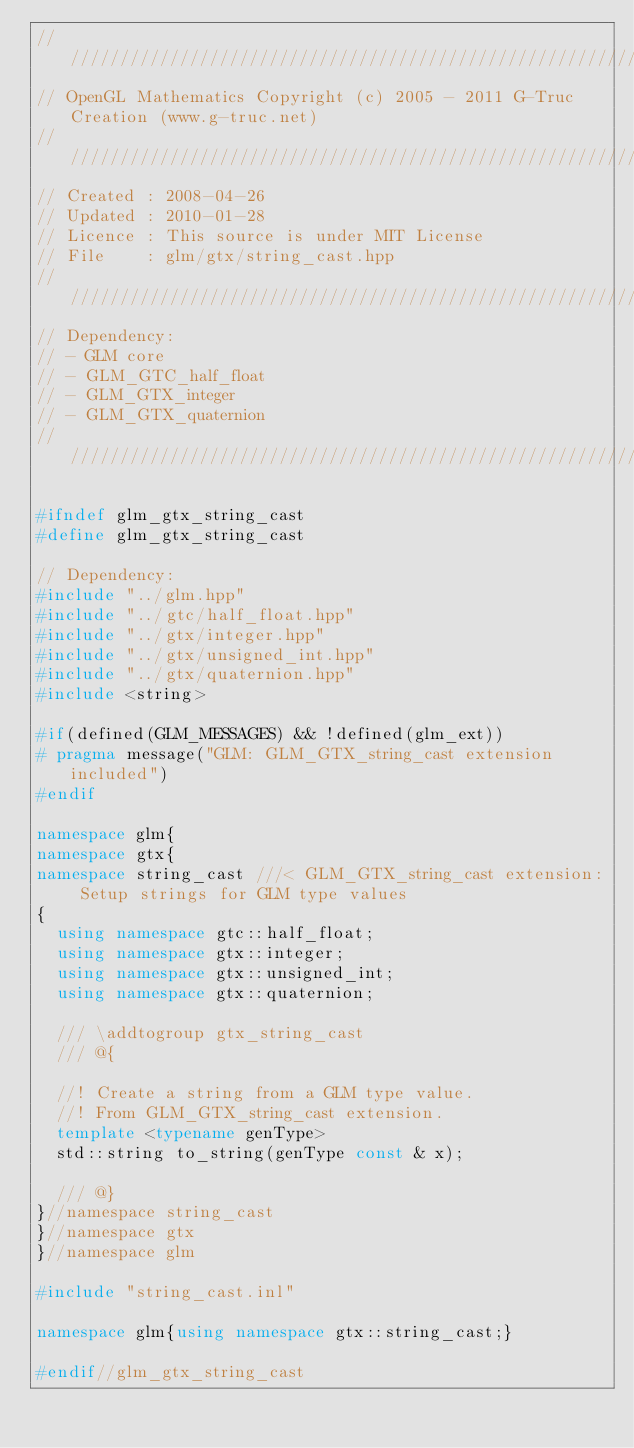<code> <loc_0><loc_0><loc_500><loc_500><_C++_>///////////////////////////////////////////////////////////////////////////////////////////////////
// OpenGL Mathematics Copyright (c) 2005 - 2011 G-Truc Creation (www.g-truc.net)
///////////////////////////////////////////////////////////////////////////////////////////////////
// Created : 2008-04-26
// Updated : 2010-01-28
// Licence : This source is under MIT License
// File    : glm/gtx/string_cast.hpp
///////////////////////////////////////////////////////////////////////////////////////////////////
// Dependency:
// - GLM core
// - GLM_GTC_half_float
// - GLM_GTX_integer
// - GLM_GTX_quaternion
///////////////////////////////////////////////////////////////////////////////////////////////////

#ifndef glm_gtx_string_cast
#define glm_gtx_string_cast

// Dependency:
#include "../glm.hpp"
#include "../gtc/half_float.hpp"
#include "../gtx/integer.hpp"
#include "../gtx/unsigned_int.hpp"
#include "../gtx/quaternion.hpp"
#include <string>

#if(defined(GLM_MESSAGES) && !defined(glm_ext))
#	pragma message("GLM: GLM_GTX_string_cast extension included")
#endif

namespace glm{
namespace gtx{
namespace string_cast ///< GLM_GTX_string_cast extension: Setup strings for GLM type values
{
	using namespace gtc::half_float; 
	using namespace gtx::integer; 
	using namespace gtx::unsigned_int; 
	using namespace gtx::quaternion; 

	/// \addtogroup gtx_string_cast
	/// @{

	//! Create a string from a GLM type value.
	//! From GLM_GTX_string_cast extension.
	template <typename genType> 
	std::string to_string(genType const & x);

	/// @}
}//namespace string_cast
}//namespace gtx
}//namespace glm

#include "string_cast.inl"

namespace glm{using namespace gtx::string_cast;}

#endif//glm_gtx_string_cast
</code> 